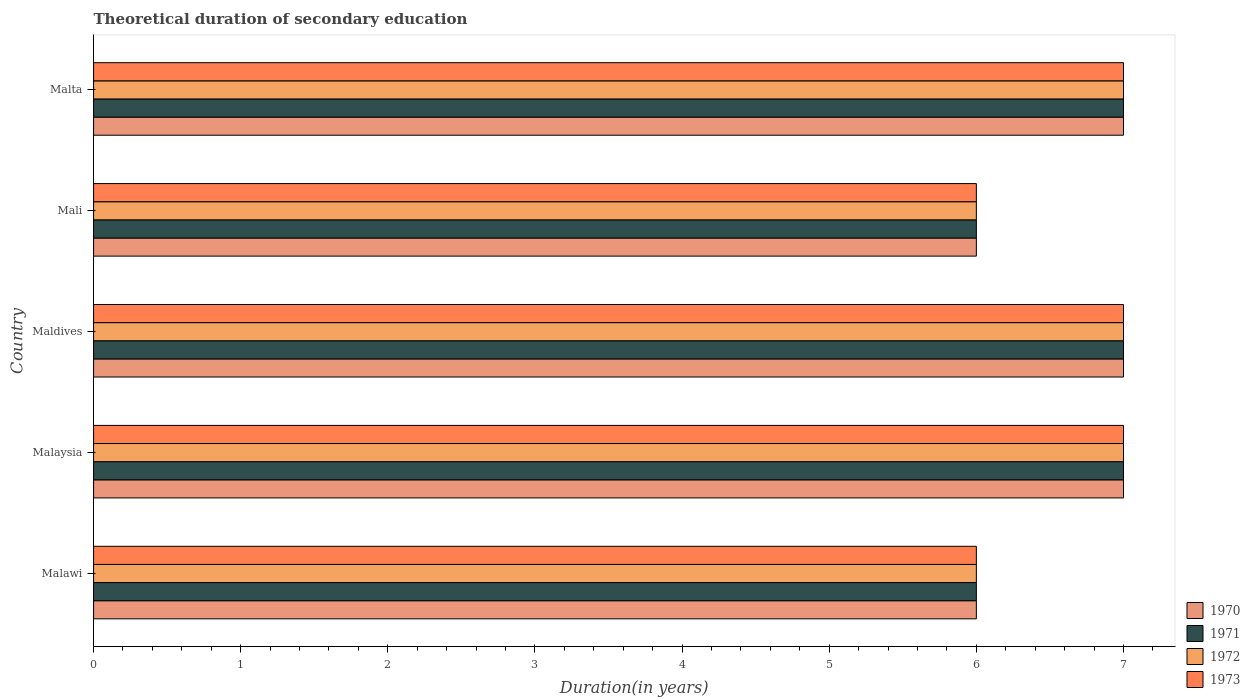How many bars are there on the 4th tick from the top?
Offer a terse response. 4. How many bars are there on the 1st tick from the bottom?
Provide a succinct answer. 4. What is the label of the 2nd group of bars from the top?
Offer a terse response. Mali. In how many cases, is the number of bars for a given country not equal to the number of legend labels?
Your answer should be very brief. 0. What is the total theoretical duration of secondary education in 1973 in Maldives?
Ensure brevity in your answer.  7. In which country was the total theoretical duration of secondary education in 1972 maximum?
Make the answer very short. Malaysia. In which country was the total theoretical duration of secondary education in 1973 minimum?
Ensure brevity in your answer.  Malawi. What is the total total theoretical duration of secondary education in 1972 in the graph?
Provide a succinct answer. 33. What is the difference between the total theoretical duration of secondary education in 1970 in Malaysia and that in Mali?
Make the answer very short. 1. What is the average total theoretical duration of secondary education in 1973 per country?
Your answer should be very brief. 6.6. What is the ratio of the total theoretical duration of secondary education in 1971 in Malawi to that in Mali?
Your response must be concise. 1. Is the difference between the total theoretical duration of secondary education in 1972 in Mali and Malta greater than the difference between the total theoretical duration of secondary education in 1971 in Mali and Malta?
Offer a very short reply. No. Is it the case that in every country, the sum of the total theoretical duration of secondary education in 1971 and total theoretical duration of secondary education in 1970 is greater than the sum of total theoretical duration of secondary education in 1973 and total theoretical duration of secondary education in 1972?
Offer a terse response. No. What does the 1st bar from the bottom in Maldives represents?
Your answer should be very brief. 1970. How many bars are there?
Offer a terse response. 20. How many countries are there in the graph?
Your answer should be very brief. 5. How many legend labels are there?
Your response must be concise. 4. How are the legend labels stacked?
Offer a very short reply. Vertical. What is the title of the graph?
Give a very brief answer. Theoretical duration of secondary education. Does "1993" appear as one of the legend labels in the graph?
Give a very brief answer. No. What is the label or title of the X-axis?
Your answer should be compact. Duration(in years). What is the label or title of the Y-axis?
Provide a short and direct response. Country. What is the Duration(in years) in 1970 in Malawi?
Your answer should be very brief. 6. What is the Duration(in years) in 1971 in Malaysia?
Make the answer very short. 7. What is the Duration(in years) of 1972 in Malaysia?
Offer a very short reply. 7. What is the Duration(in years) in 1973 in Malaysia?
Offer a very short reply. 7. What is the Duration(in years) in 1970 in Maldives?
Provide a succinct answer. 7. What is the Duration(in years) in 1971 in Maldives?
Make the answer very short. 7. What is the Duration(in years) of 1973 in Maldives?
Give a very brief answer. 7. What is the Duration(in years) of 1970 in Malta?
Ensure brevity in your answer.  7. What is the Duration(in years) in 1972 in Malta?
Offer a terse response. 7. Across all countries, what is the maximum Duration(in years) of 1973?
Keep it short and to the point. 7. Across all countries, what is the minimum Duration(in years) in 1973?
Your answer should be very brief. 6. What is the total Duration(in years) of 1971 in the graph?
Your response must be concise. 33. What is the difference between the Duration(in years) in 1971 in Malawi and that in Malaysia?
Provide a succinct answer. -1. What is the difference between the Duration(in years) in 1973 in Malawi and that in Malaysia?
Offer a very short reply. -1. What is the difference between the Duration(in years) of 1971 in Malawi and that in Maldives?
Give a very brief answer. -1. What is the difference between the Duration(in years) in 1972 in Malawi and that in Maldives?
Give a very brief answer. -1. What is the difference between the Duration(in years) in 1972 in Malawi and that in Mali?
Provide a succinct answer. 0. What is the difference between the Duration(in years) in 1970 in Malawi and that in Malta?
Give a very brief answer. -1. What is the difference between the Duration(in years) of 1971 in Malawi and that in Malta?
Offer a terse response. -1. What is the difference between the Duration(in years) of 1972 in Malawi and that in Malta?
Offer a terse response. -1. What is the difference between the Duration(in years) of 1973 in Malawi and that in Malta?
Offer a very short reply. -1. What is the difference between the Duration(in years) in 1972 in Malaysia and that in Maldives?
Offer a very short reply. 0. What is the difference between the Duration(in years) of 1971 in Malaysia and that in Mali?
Offer a very short reply. 1. What is the difference between the Duration(in years) of 1973 in Malaysia and that in Mali?
Offer a very short reply. 1. What is the difference between the Duration(in years) of 1971 in Malaysia and that in Malta?
Provide a succinct answer. 0. What is the difference between the Duration(in years) in 1971 in Maldives and that in Mali?
Your response must be concise. 1. What is the difference between the Duration(in years) of 1972 in Maldives and that in Mali?
Give a very brief answer. 1. What is the difference between the Duration(in years) in 1973 in Maldives and that in Mali?
Provide a short and direct response. 1. What is the difference between the Duration(in years) in 1970 in Maldives and that in Malta?
Keep it short and to the point. 0. What is the difference between the Duration(in years) in 1971 in Maldives and that in Malta?
Offer a terse response. 0. What is the difference between the Duration(in years) of 1973 in Mali and that in Malta?
Your answer should be very brief. -1. What is the difference between the Duration(in years) in 1970 in Malawi and the Duration(in years) in 1971 in Malaysia?
Offer a very short reply. -1. What is the difference between the Duration(in years) in 1970 in Malawi and the Duration(in years) in 1972 in Malaysia?
Your response must be concise. -1. What is the difference between the Duration(in years) in 1970 in Malawi and the Duration(in years) in 1971 in Maldives?
Keep it short and to the point. -1. What is the difference between the Duration(in years) in 1970 in Malawi and the Duration(in years) in 1973 in Maldives?
Provide a short and direct response. -1. What is the difference between the Duration(in years) in 1971 in Malawi and the Duration(in years) in 1972 in Maldives?
Offer a terse response. -1. What is the difference between the Duration(in years) in 1972 in Malawi and the Duration(in years) in 1973 in Maldives?
Make the answer very short. -1. What is the difference between the Duration(in years) of 1970 in Malawi and the Duration(in years) of 1971 in Mali?
Your answer should be very brief. 0. What is the difference between the Duration(in years) in 1970 in Malawi and the Duration(in years) in 1973 in Mali?
Your response must be concise. 0. What is the difference between the Duration(in years) of 1971 in Malawi and the Duration(in years) of 1973 in Mali?
Provide a short and direct response. 0. What is the difference between the Duration(in years) in 1972 in Malawi and the Duration(in years) in 1973 in Mali?
Your response must be concise. 0. What is the difference between the Duration(in years) in 1970 in Malawi and the Duration(in years) in 1971 in Malta?
Your answer should be compact. -1. What is the difference between the Duration(in years) in 1970 in Malawi and the Duration(in years) in 1973 in Malta?
Keep it short and to the point. -1. What is the difference between the Duration(in years) of 1971 in Malawi and the Duration(in years) of 1972 in Malta?
Your answer should be very brief. -1. What is the difference between the Duration(in years) in 1971 in Malawi and the Duration(in years) in 1973 in Malta?
Your response must be concise. -1. What is the difference between the Duration(in years) of 1972 in Malawi and the Duration(in years) of 1973 in Malta?
Offer a very short reply. -1. What is the difference between the Duration(in years) of 1970 in Malaysia and the Duration(in years) of 1972 in Maldives?
Make the answer very short. 0. What is the difference between the Duration(in years) in 1970 in Malaysia and the Duration(in years) in 1973 in Maldives?
Your answer should be very brief. 0. What is the difference between the Duration(in years) in 1971 in Malaysia and the Duration(in years) in 1973 in Maldives?
Give a very brief answer. 0. What is the difference between the Duration(in years) of 1970 in Malaysia and the Duration(in years) of 1971 in Mali?
Make the answer very short. 1. What is the difference between the Duration(in years) in 1970 in Malaysia and the Duration(in years) in 1972 in Mali?
Give a very brief answer. 1. What is the difference between the Duration(in years) of 1970 in Malaysia and the Duration(in years) of 1973 in Mali?
Offer a very short reply. 1. What is the difference between the Duration(in years) of 1971 in Malaysia and the Duration(in years) of 1972 in Mali?
Provide a short and direct response. 1. What is the difference between the Duration(in years) in 1971 in Malaysia and the Duration(in years) in 1973 in Mali?
Provide a short and direct response. 1. What is the difference between the Duration(in years) of 1970 in Malaysia and the Duration(in years) of 1971 in Malta?
Your answer should be very brief. 0. What is the difference between the Duration(in years) in 1970 in Malaysia and the Duration(in years) in 1973 in Malta?
Keep it short and to the point. 0. What is the difference between the Duration(in years) in 1971 in Malaysia and the Duration(in years) in 1973 in Malta?
Your answer should be very brief. 0. What is the difference between the Duration(in years) of 1971 in Maldives and the Duration(in years) of 1972 in Mali?
Provide a short and direct response. 1. What is the difference between the Duration(in years) of 1971 in Maldives and the Duration(in years) of 1973 in Mali?
Keep it short and to the point. 1. What is the difference between the Duration(in years) in 1970 in Maldives and the Duration(in years) in 1971 in Malta?
Your response must be concise. 0. What is the difference between the Duration(in years) in 1971 in Maldives and the Duration(in years) in 1972 in Malta?
Provide a succinct answer. 0. What is the difference between the Duration(in years) of 1971 in Mali and the Duration(in years) of 1973 in Malta?
Offer a very short reply. -1. What is the average Duration(in years) in 1970 per country?
Offer a very short reply. 6.6. What is the average Duration(in years) of 1972 per country?
Provide a succinct answer. 6.6. What is the difference between the Duration(in years) of 1970 and Duration(in years) of 1971 in Malawi?
Keep it short and to the point. 0. What is the difference between the Duration(in years) in 1970 and Duration(in years) in 1971 in Malaysia?
Give a very brief answer. 0. What is the difference between the Duration(in years) in 1970 and Duration(in years) in 1973 in Malaysia?
Your answer should be compact. 0. What is the difference between the Duration(in years) in 1971 and Duration(in years) in 1973 in Malaysia?
Ensure brevity in your answer.  0. What is the difference between the Duration(in years) of 1972 and Duration(in years) of 1973 in Malaysia?
Make the answer very short. 0. What is the difference between the Duration(in years) of 1970 and Duration(in years) of 1973 in Maldives?
Offer a very short reply. 0. What is the difference between the Duration(in years) of 1971 and Duration(in years) of 1973 in Maldives?
Give a very brief answer. 0. What is the difference between the Duration(in years) of 1970 and Duration(in years) of 1971 in Mali?
Give a very brief answer. 0. What is the difference between the Duration(in years) in 1970 and Duration(in years) in 1972 in Mali?
Your answer should be very brief. 0. What is the difference between the Duration(in years) of 1971 and Duration(in years) of 1973 in Mali?
Keep it short and to the point. 0. What is the difference between the Duration(in years) in 1971 and Duration(in years) in 1973 in Malta?
Your answer should be very brief. 0. What is the ratio of the Duration(in years) of 1970 in Malawi to that in Malaysia?
Give a very brief answer. 0.86. What is the ratio of the Duration(in years) in 1973 in Malawi to that in Malaysia?
Your answer should be compact. 0.86. What is the ratio of the Duration(in years) of 1971 in Malawi to that in Maldives?
Your answer should be compact. 0.86. What is the ratio of the Duration(in years) of 1972 in Malawi to that in Maldives?
Offer a terse response. 0.86. What is the ratio of the Duration(in years) of 1973 in Malawi to that in Maldives?
Give a very brief answer. 0.86. What is the ratio of the Duration(in years) in 1970 in Malawi to that in Mali?
Make the answer very short. 1. What is the ratio of the Duration(in years) of 1970 in Malawi to that in Malta?
Your answer should be very brief. 0.86. What is the ratio of the Duration(in years) in 1971 in Malawi to that in Malta?
Offer a terse response. 0.86. What is the ratio of the Duration(in years) of 1973 in Malawi to that in Malta?
Provide a succinct answer. 0.86. What is the ratio of the Duration(in years) of 1970 in Malaysia to that in Maldives?
Give a very brief answer. 1. What is the ratio of the Duration(in years) in 1970 in Malaysia to that in Mali?
Keep it short and to the point. 1.17. What is the ratio of the Duration(in years) in 1971 in Malaysia to that in Mali?
Make the answer very short. 1.17. What is the ratio of the Duration(in years) in 1973 in Malaysia to that in Mali?
Provide a succinct answer. 1.17. What is the ratio of the Duration(in years) in 1973 in Malaysia to that in Malta?
Your response must be concise. 1. What is the ratio of the Duration(in years) of 1971 in Maldives to that in Mali?
Ensure brevity in your answer.  1.17. What is the ratio of the Duration(in years) in 1972 in Maldives to that in Mali?
Offer a terse response. 1.17. What is the ratio of the Duration(in years) in 1973 in Maldives to that in Mali?
Ensure brevity in your answer.  1.17. What is the ratio of the Duration(in years) in 1971 in Maldives to that in Malta?
Your answer should be compact. 1. What is the ratio of the Duration(in years) of 1973 in Maldives to that in Malta?
Your response must be concise. 1. What is the difference between the highest and the second highest Duration(in years) in 1973?
Your response must be concise. 0. What is the difference between the highest and the lowest Duration(in years) of 1972?
Make the answer very short. 1. 